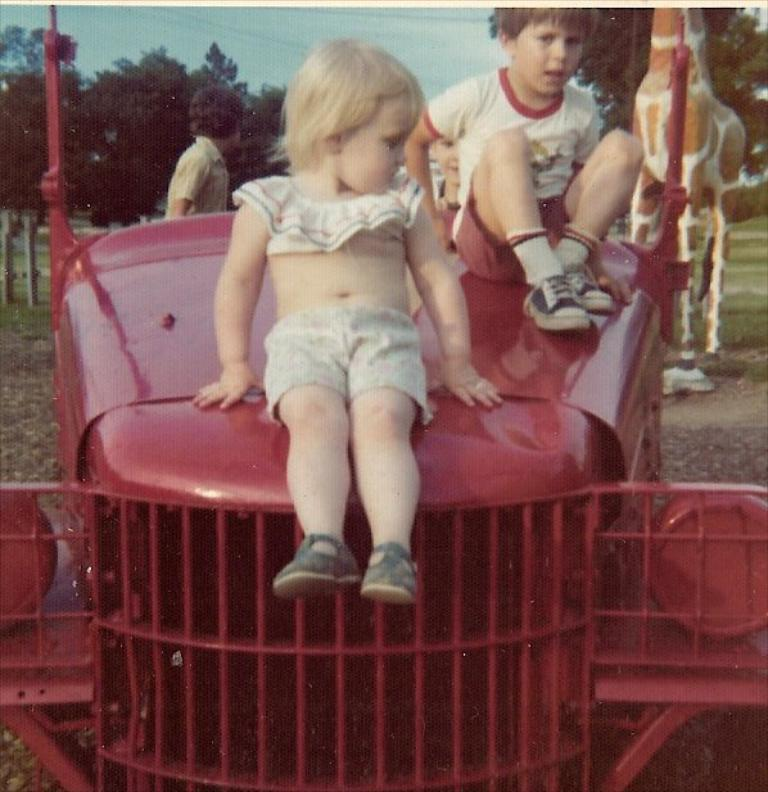What are the two people sitting on in the image? The two people are sitting on a tractor-shaped toy. Where is the toy located in the image? The toy is on the ground. What can be seen in the background of the image? There are people, a giraffe, metal poles, trees, and the sky visible in the background of the image. What type of root can be seen growing from the giraffe's mouth in the image? There is no root growing from the giraffe's mouth in the image, as the giraffe is not a plant and does not have roots. 